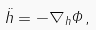<formula> <loc_0><loc_0><loc_500><loc_500>\ddot { h } = - \nabla _ { h } \Phi \, ,</formula> 